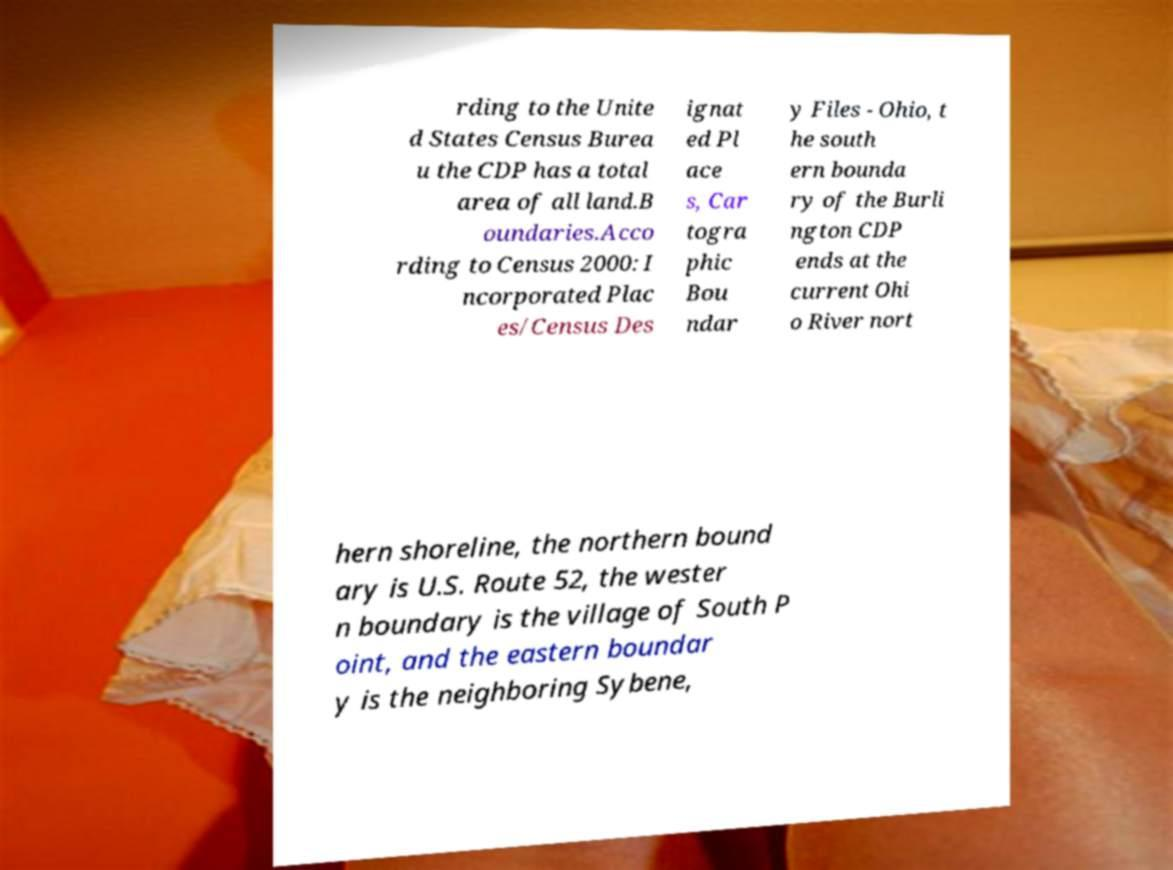For documentation purposes, I need the text within this image transcribed. Could you provide that? rding to the Unite d States Census Burea u the CDP has a total area of all land.B oundaries.Acco rding to Census 2000: I ncorporated Plac es/Census Des ignat ed Pl ace s, Car togra phic Bou ndar y Files - Ohio, t he south ern bounda ry of the Burli ngton CDP ends at the current Ohi o River nort hern shoreline, the northern bound ary is U.S. Route 52, the wester n boundary is the village of South P oint, and the eastern boundar y is the neighboring Sybene, 